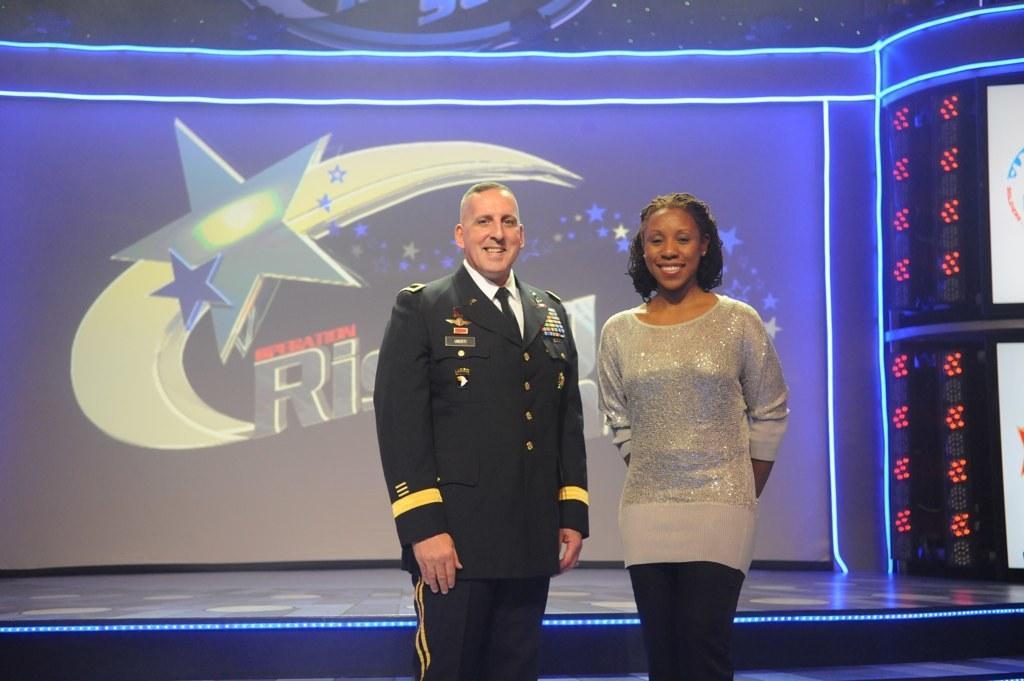Describe this image in one or two sentences. In this picture we can see 2 people standing on the stage and looking and smiling at someone. In the background, we can see lights, stars, moon and some text on the display. 